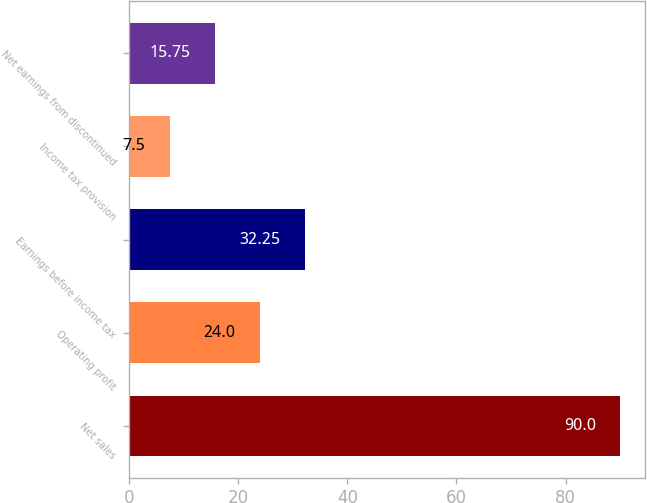Convert chart to OTSL. <chart><loc_0><loc_0><loc_500><loc_500><bar_chart><fcel>Net sales<fcel>Operating profit<fcel>Earnings before income tax<fcel>Income tax provision<fcel>Net earnings from discontinued<nl><fcel>90<fcel>24<fcel>32.25<fcel>7.5<fcel>15.75<nl></chart> 